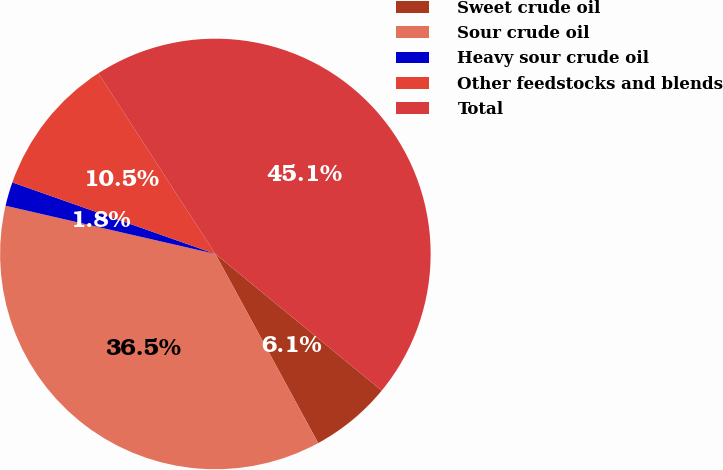<chart> <loc_0><loc_0><loc_500><loc_500><pie_chart><fcel>Sweet crude oil<fcel>Sour crude oil<fcel>Heavy sour crude oil<fcel>Other feedstocks and blends<fcel>Total<nl><fcel>6.13%<fcel>36.52%<fcel>1.8%<fcel>10.46%<fcel>45.09%<nl></chart> 